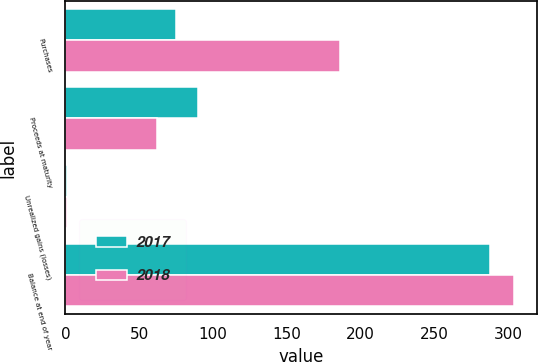Convert chart to OTSL. <chart><loc_0><loc_0><loc_500><loc_500><stacked_bar_chart><ecel><fcel>Purchases<fcel>Proceeds at maturity<fcel>Unrealized gains (losses)<fcel>Balance at end of year<nl><fcel>2017<fcel>75<fcel>90<fcel>1<fcel>288<nl><fcel>2018<fcel>186<fcel>62<fcel>1<fcel>304<nl></chart> 